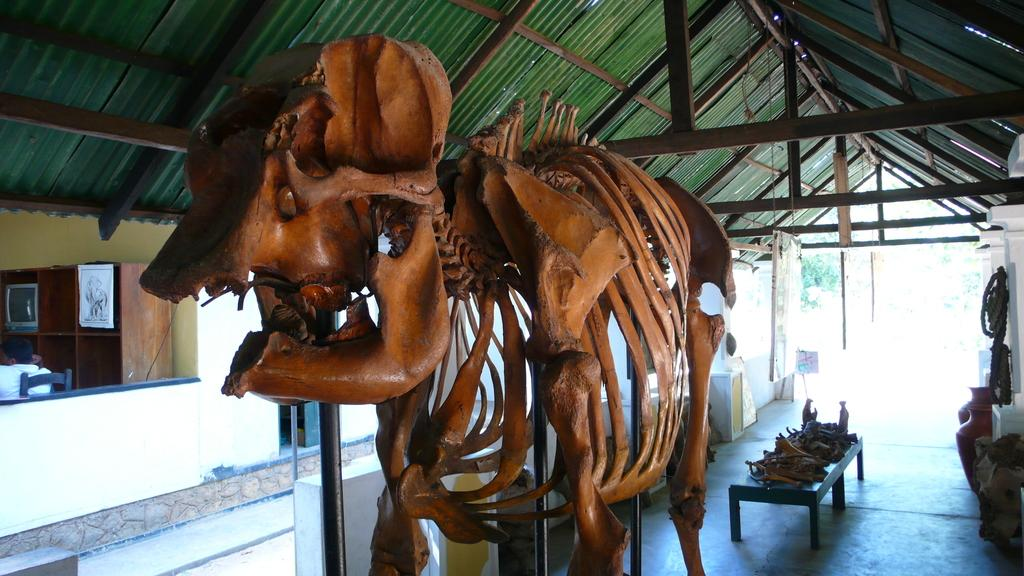What is the main subject of the image? The main subject of the image is a skeleton of an animal. What furniture is present in the image? There is a table and a chair in the image. What other objects can be seen in the image? There is a cupboard and a television in the image. What type of wire is being used to hold the lettuce in the image? There is no lettuce or wire present in the image. Can you tell me how many kittens are sitting on the table in the image? There are no kittens present in the image; the main subject is the skeleton of an animal. 